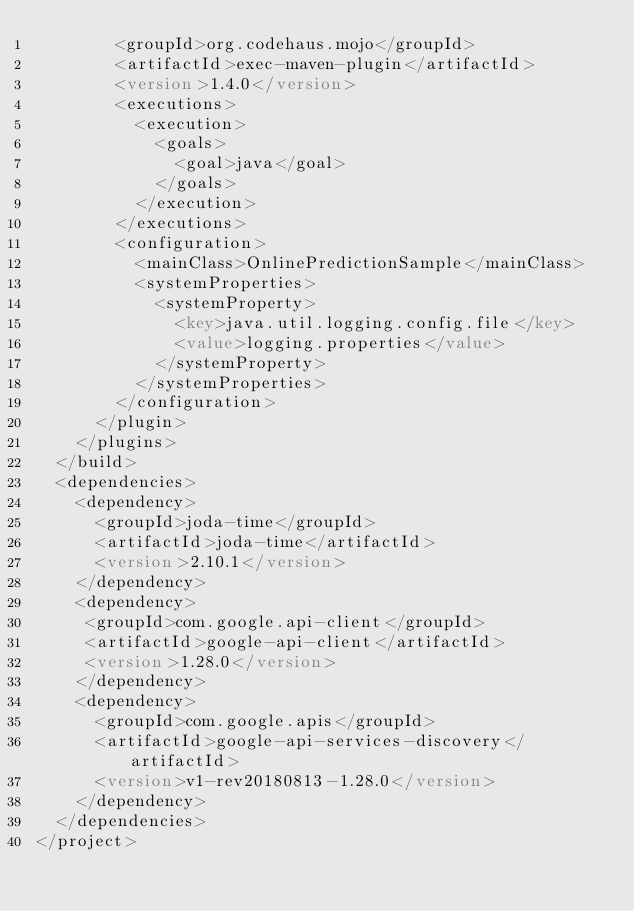Convert code to text. <code><loc_0><loc_0><loc_500><loc_500><_XML_>        <groupId>org.codehaus.mojo</groupId>
        <artifactId>exec-maven-plugin</artifactId>
        <version>1.4.0</version>
        <executions>
          <execution>
            <goals>
              <goal>java</goal>
            </goals>
          </execution>
        </executions>
        <configuration>
          <mainClass>OnlinePredictionSample</mainClass>
          <systemProperties>
            <systemProperty>
              <key>java.util.logging.config.file</key>
              <value>logging.properties</value>
            </systemProperty>
          </systemProperties>
        </configuration>
      </plugin>
    </plugins>
  </build>
  <dependencies>
    <dependency>
      <groupId>joda-time</groupId>
      <artifactId>joda-time</artifactId>
      <version>2.10.1</version>
    </dependency>
    <dependency>
     <groupId>com.google.api-client</groupId>
     <artifactId>google-api-client</artifactId>
     <version>1.28.0</version>
    </dependency>
    <dependency>
      <groupId>com.google.apis</groupId>
      <artifactId>google-api-services-discovery</artifactId>
      <version>v1-rev20180813-1.28.0</version>
    </dependency>
  </dependencies>
</project>
</code> 